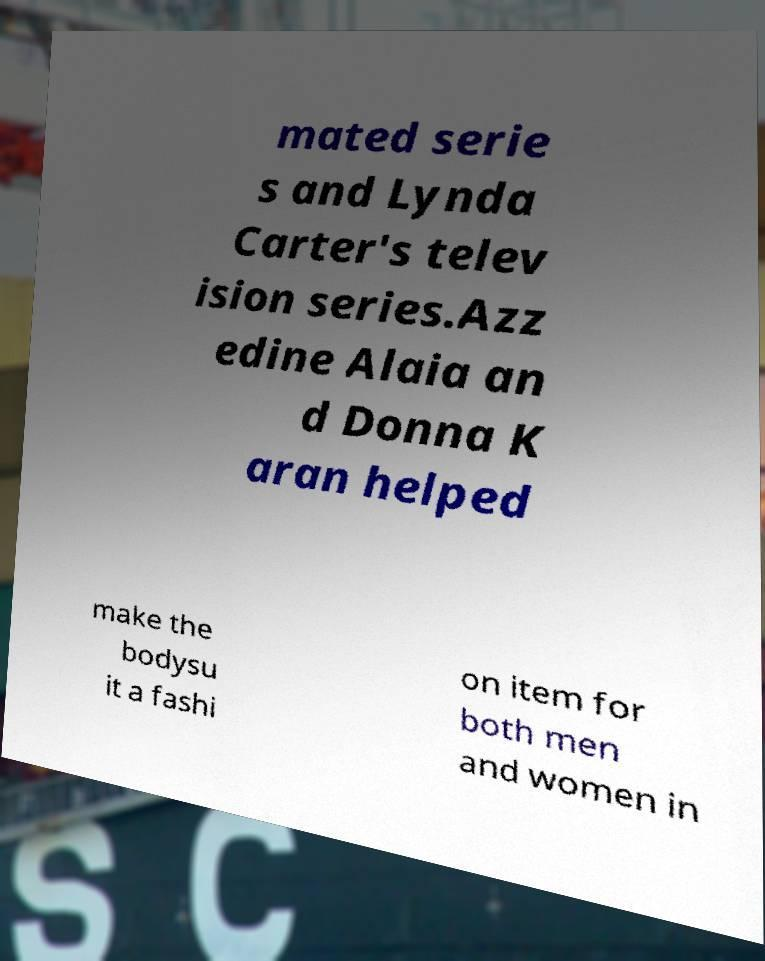I need the written content from this picture converted into text. Can you do that? mated serie s and Lynda Carter's telev ision series.Azz edine Alaia an d Donna K aran helped make the bodysu it a fashi on item for both men and women in 